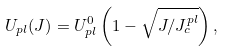<formula> <loc_0><loc_0><loc_500><loc_500>U _ { p l } ( J ) = U _ { p l } ^ { 0 } \left ( 1 - \sqrt { J / J _ { c } ^ { p l } } \right ) ,</formula> 